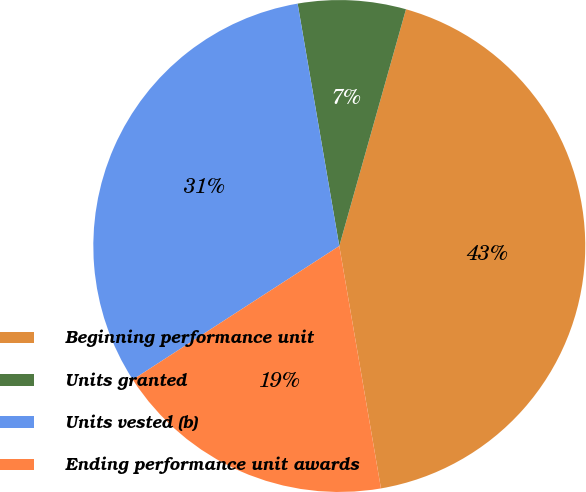Convert chart. <chart><loc_0><loc_0><loc_500><loc_500><pie_chart><fcel>Beginning performance unit<fcel>Units granted<fcel>Units vested (b)<fcel>Ending performance unit awards<nl><fcel>42.92%<fcel>7.08%<fcel>31.43%<fcel>18.57%<nl></chart> 